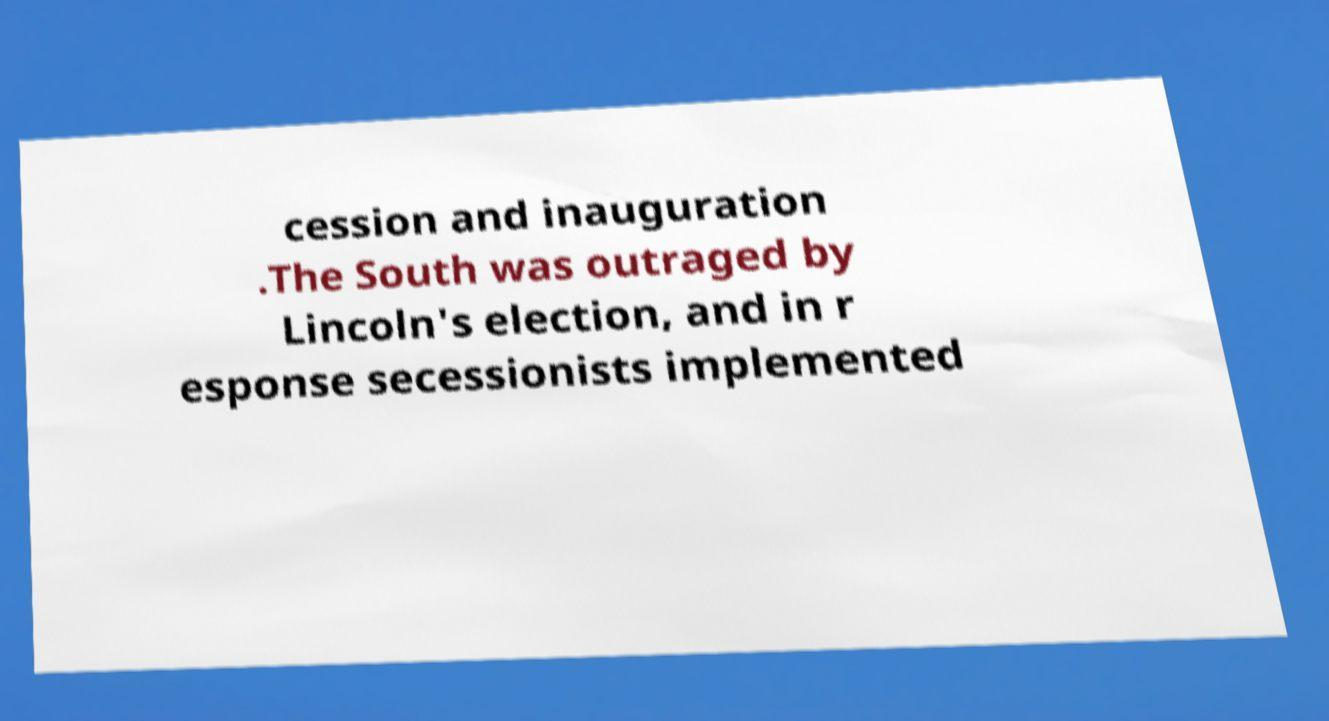Could you extract and type out the text from this image? cession and inauguration .The South was outraged by Lincoln's election, and in r esponse secessionists implemented 